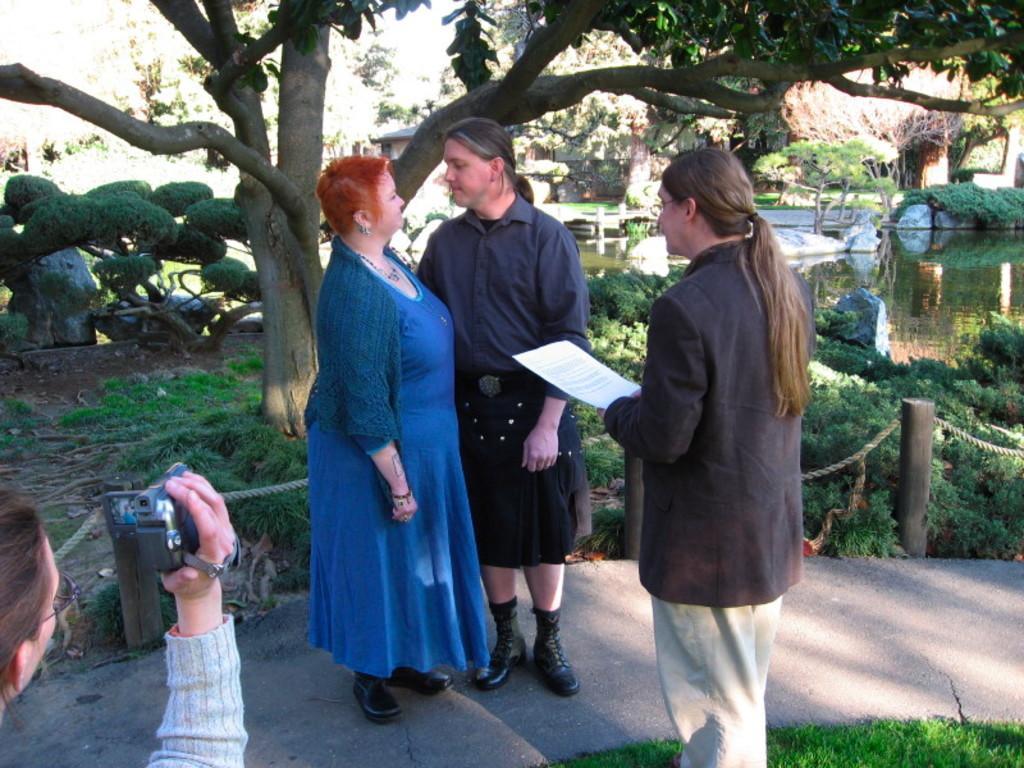How would you summarize this image in a sentence or two? In this picture we can see four people standing on a path were two are looking at each other and a woman holding a paper with her hand, camera, wooden poles, ropes, water, stones and trees. 